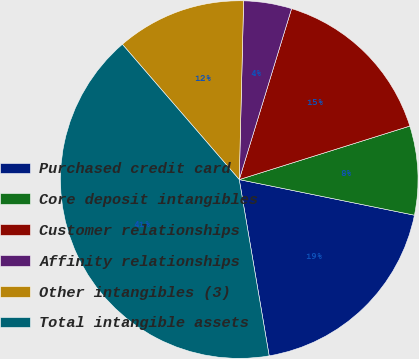<chart> <loc_0><loc_0><loc_500><loc_500><pie_chart><fcel>Purchased credit card<fcel>Core deposit intangibles<fcel>Customer relationships<fcel>Affinity relationships<fcel>Other intangibles (3)<fcel>Total intangible assets<nl><fcel>19.13%<fcel>8.03%<fcel>15.43%<fcel>4.34%<fcel>11.73%<fcel>41.33%<nl></chart> 